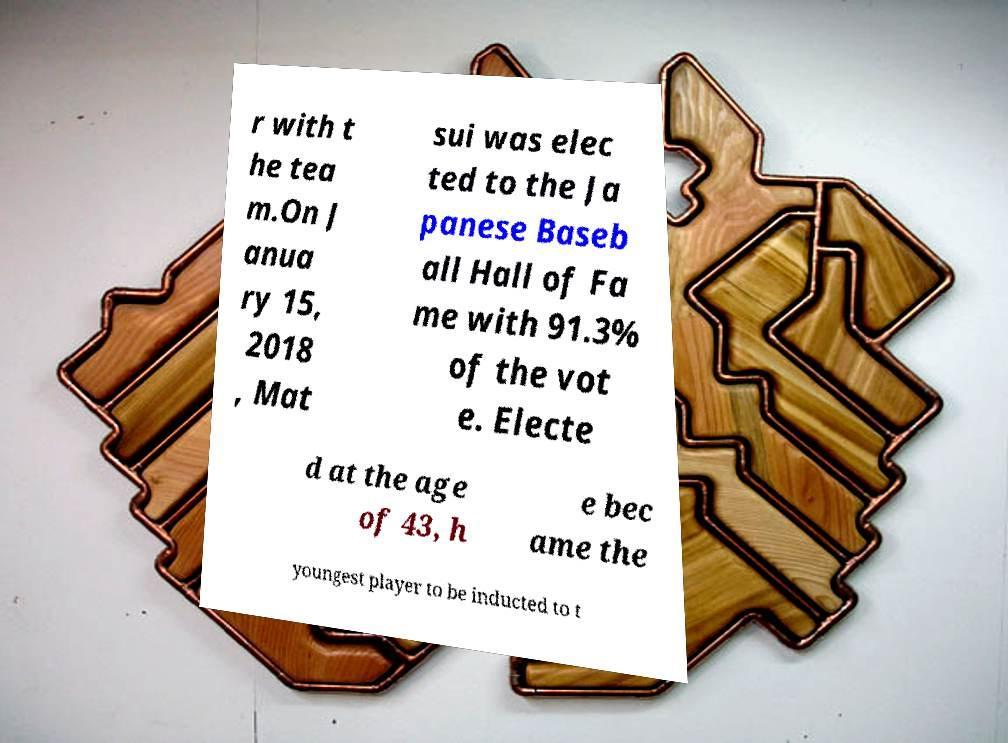Can you accurately transcribe the text from the provided image for me? r with t he tea m.On J anua ry 15, 2018 , Mat sui was elec ted to the Ja panese Baseb all Hall of Fa me with 91.3% of the vot e. Electe d at the age of 43, h e bec ame the youngest player to be inducted to t 